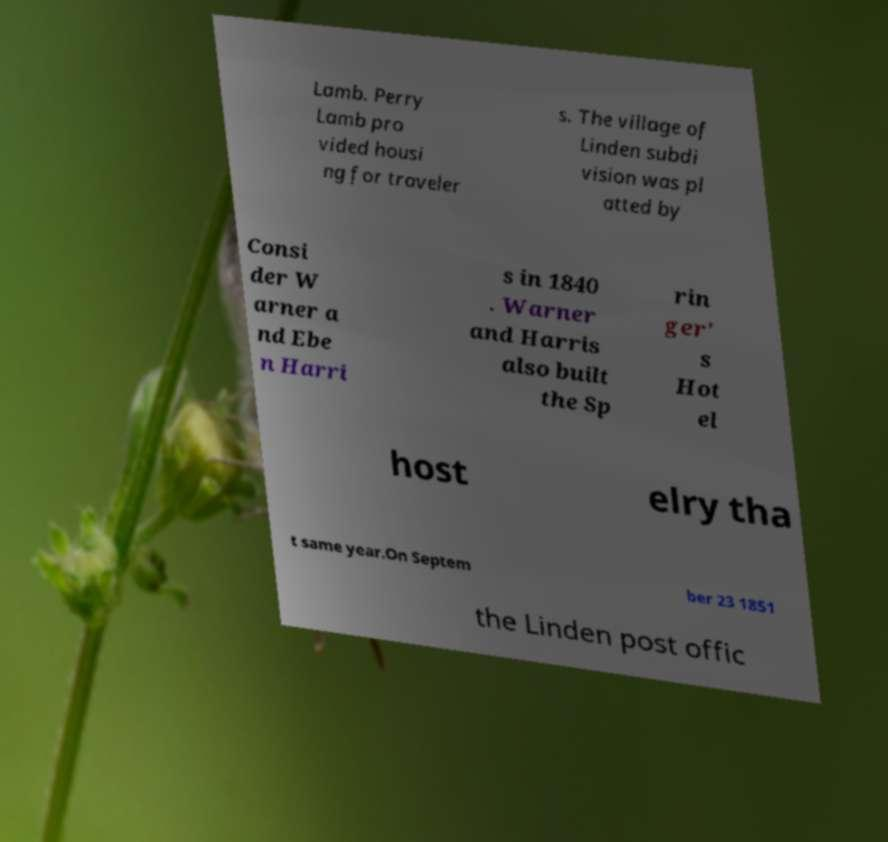Can you accurately transcribe the text from the provided image for me? Lamb. Perry Lamb pro vided housi ng for traveler s. The village of Linden subdi vision was pl atted by Consi der W arner a nd Ebe n Harri s in 1840 . Warner and Harris also built the Sp rin ger' s Hot el host elry tha t same year.On Septem ber 23 1851 the Linden post offic 